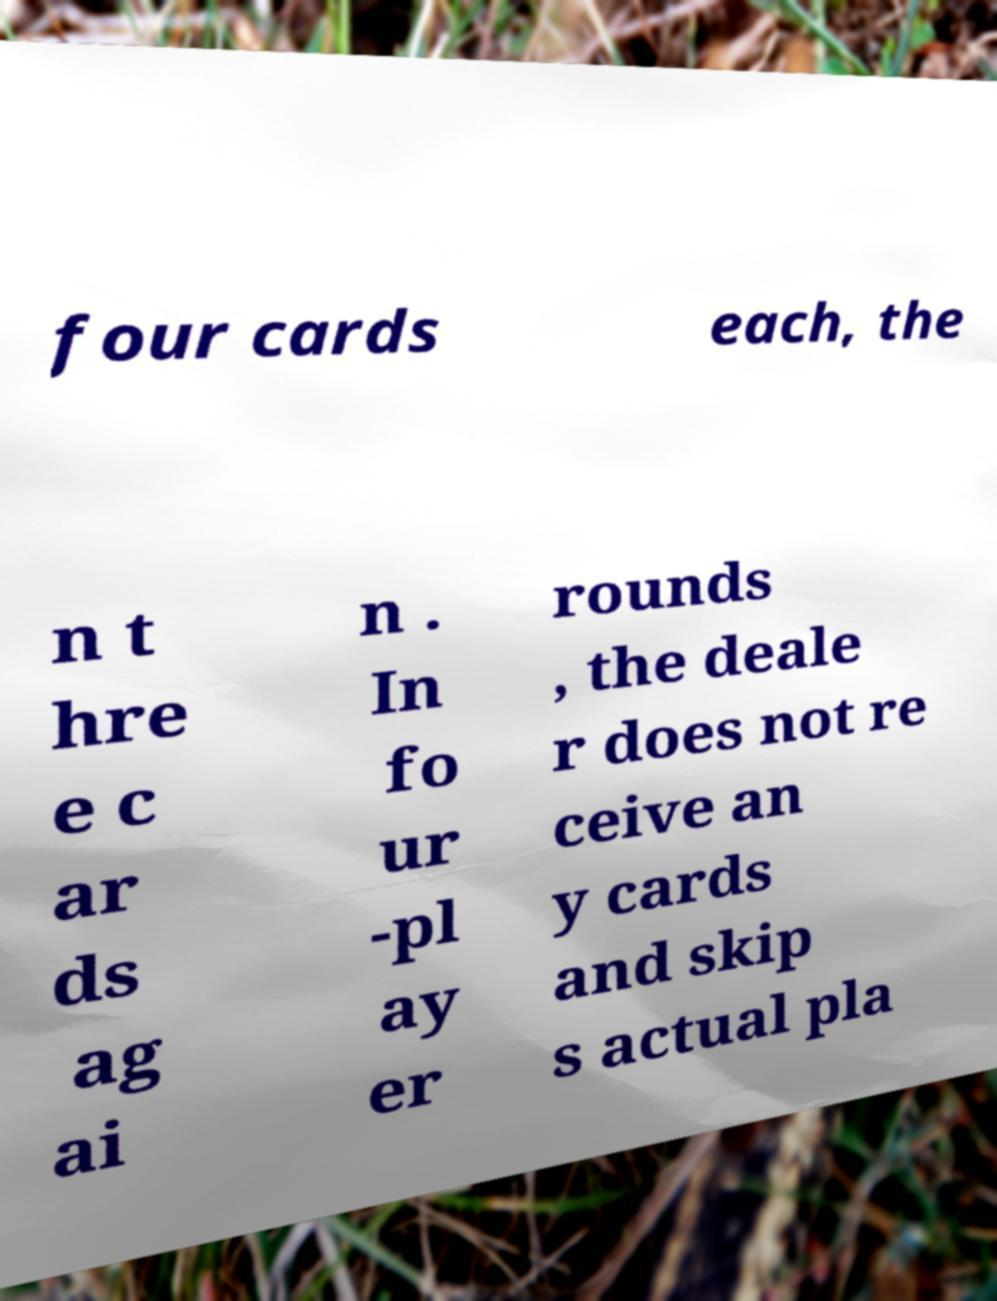I need the written content from this picture converted into text. Can you do that? four cards each, the n t hre e c ar ds ag ai n . In fo ur -pl ay er rounds , the deale r does not re ceive an y cards and skip s actual pla 